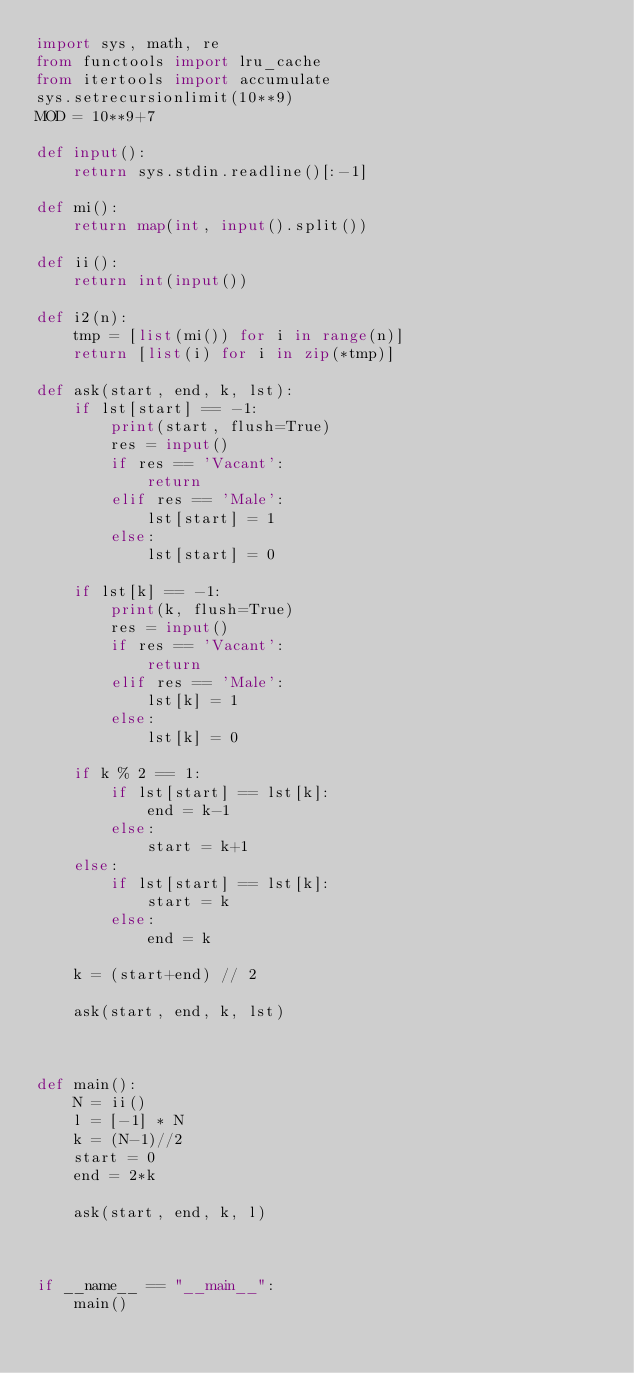Convert code to text. <code><loc_0><loc_0><loc_500><loc_500><_Python_>import sys, math, re
from functools import lru_cache
from itertools import accumulate
sys.setrecursionlimit(10**9)
MOD = 10**9+7

def input():
    return sys.stdin.readline()[:-1]

def mi():
    return map(int, input().split())

def ii():
    return int(input())

def i2(n):
    tmp = [list(mi()) for i in range(n)]
    return [list(i) for i in zip(*tmp)]

def ask(start, end, k, lst):
    if lst[start] == -1:
        print(start, flush=True)
        res = input()
        if res == 'Vacant':
            return
        elif res == 'Male':
            lst[start] = 1
        else:
            lst[start] = 0

    if lst[k] == -1:
        print(k, flush=True)
        res = input()
        if res == 'Vacant':
            return
        elif res == 'Male':
            lst[k] = 1
        else:
            lst[k] = 0

    if k % 2 == 1:
        if lst[start] == lst[k]:
            end = k-1
        else:
            start = k+1
    else:
        if lst[start] == lst[k]:
            start = k
        else:
            end = k

    k = (start+end) // 2

    ask(start, end, k, lst)
        


def main():
    N = ii()
    l = [-1] * N
    k = (N-1)//2
    start = 0
    end = 2*k

    ask(start, end, k, l)



if __name__ == "__main__":
    main()</code> 